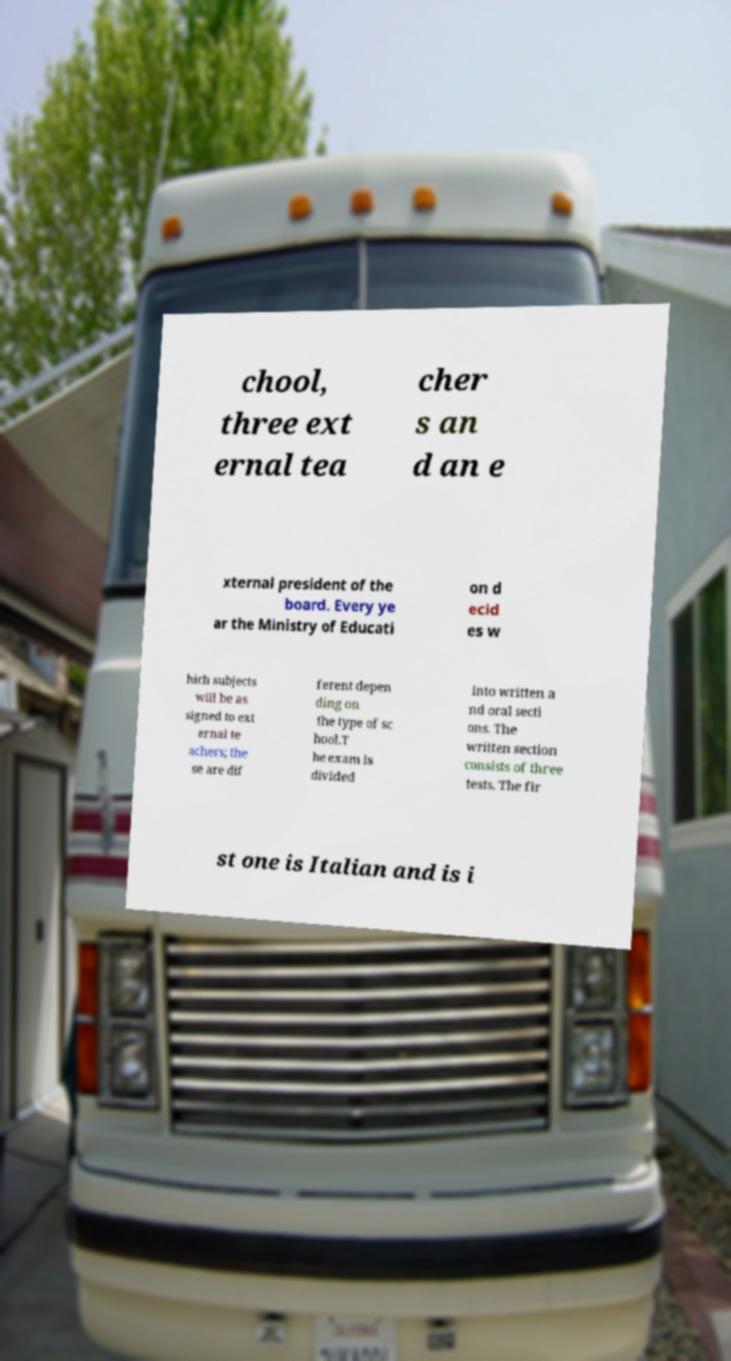Please read and relay the text visible in this image. What does it say? chool, three ext ernal tea cher s an d an e xternal president of the board. Every ye ar the Ministry of Educati on d ecid es w hich subjects will be as signed to ext ernal te achers; the se are dif ferent depen ding on the type of sc hool.T he exam is divided into written a nd oral secti ons. The written section consists of three tests. The fir st one is Italian and is i 